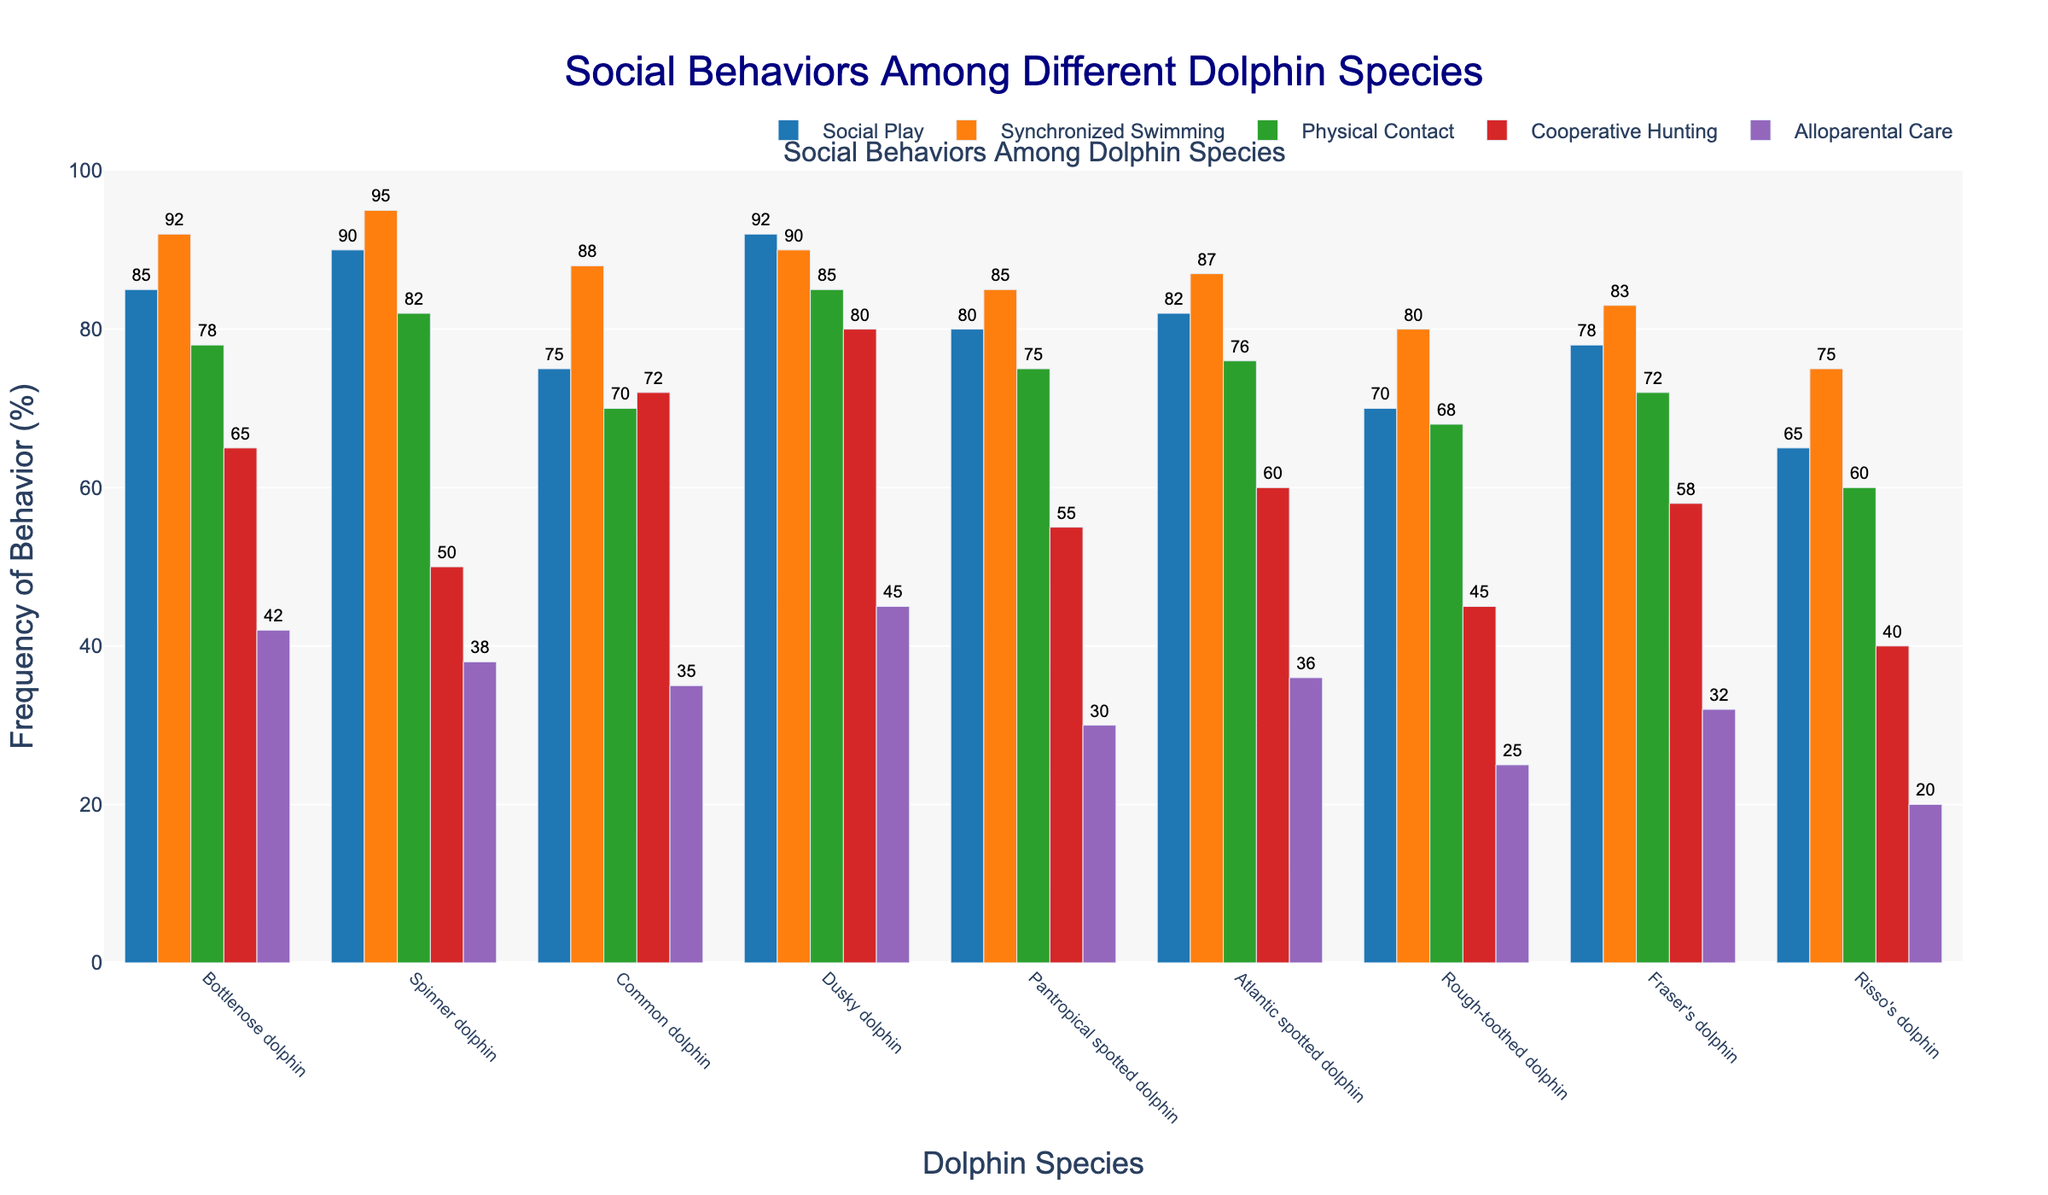What is the total frequency of cooperative hunting for Bottlenose and Dusky dolphins? To find the total frequency of cooperative hunting for these dolphins, add the cooperative hunting values for Bottlenose (65) and Dusky dolphins (80): 65 + 80 = 145.
Answer: 145 Which dolphin species has the highest frequency of synchronized swimming? Check the synchronized swimming category for each species and identify the maximum value. The highest frequency of synchronized swimming is 95, observed in Spinner dolphins.
Answer: Spinner dolphin Which dolphin species exhibits the least alloparental care? Check the alloparental care category for each species and identify the minimum value. The least alloparental care is 20, observed in Risso's dolphins.
Answer: Risso's dolphin Compare the social play frequency between Common dolphins and Rough-toothed dolphins. Which is higher? Look at the social play values for Common dolphins (75) and Rough-toothed dolphins (70). 75 is greater than 70, so Common dolphins have a higher social play frequency.
Answer: Common dolphin What is the average frequency of physical contact among the Atlantic spotted and Pantropical spotted dolphins? The average frequency of physical contact is calculated by adding Atlantic spotted (76) and Pantropical spotted dolphins (75) values and dividing by 2: (76 + 75)/2 = 75.5.
Answer: 75.5 Which social behavior is the least frequent among all observed behaviors across all species? Identify the minimum value in all behavioral categories. The lowest value across all behaviors is 20 in the alloparental care category for Risso's dolphins.
Answer: Alloparental care by Risso’s dolphins How does the frequency of cooperative hunting in Fraser's dolphins compare to that of Spinner dolphins? Compare the cooperative hunting values for Fraser's dolphins (58) and Spinner dolphins (50). 58 is greater than 50, so Fraser's dolphins have a higher frequency.
Answer: Fraser's dolphin Which dolphin species has the closest frequencies between social play and synchronized swimming? Find the species with the smallest difference between social play and synchronized swimming frequencies. Dusky dolphins have a 2% difference (92 for play, 90 for swimming).
Answer: Dusky dolphin What is the sum of the frequencies of synchronized swimming across all species? Add the synchronized swimming frequencies for all species: 92 + 95 + 88 + 90 + 85 + 87 + 80 + 83 + 75 = 775.
Answer: 775 Among Bottlenose dolphins, which behavior is more frequent: social play or alloparental care? Compare the social play (85) and alloparental care (42) values for Bottlenose dolphins. 85 is greater than 42, so social play is more frequent.
Answer: Social play What is the median frequency of alloparental care among all species? To find the median, first list the alloparental care values in ascending order: 20, 25, 30, 32, 35, 36, 38, 42, 45. The median value is the fifth value in this ordered list, which is 35.
Answer: 35 